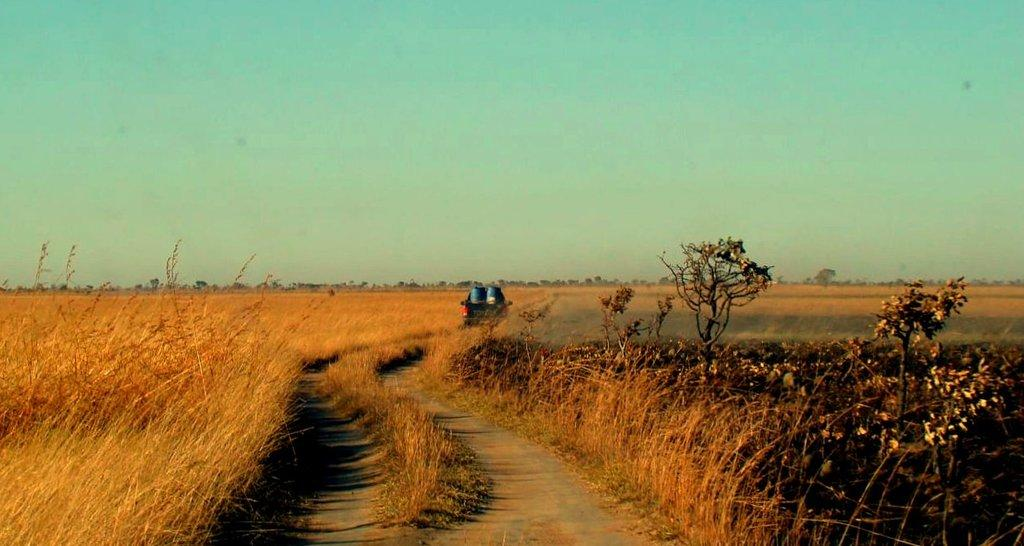What type of vegetation can be seen in the image? There is grass, plants, and trees visible in the image. What else can be seen on the surface in the image? There is a vehicle visible on the surface. What is visible in the background of the image? There are trees and the sky visible in the background of the image. What type of pen can be seen in the image? There is no pen present in the image. What is the voice of the tree in the image? Trees do not have voices, and there is no indication of any voice in the image. 